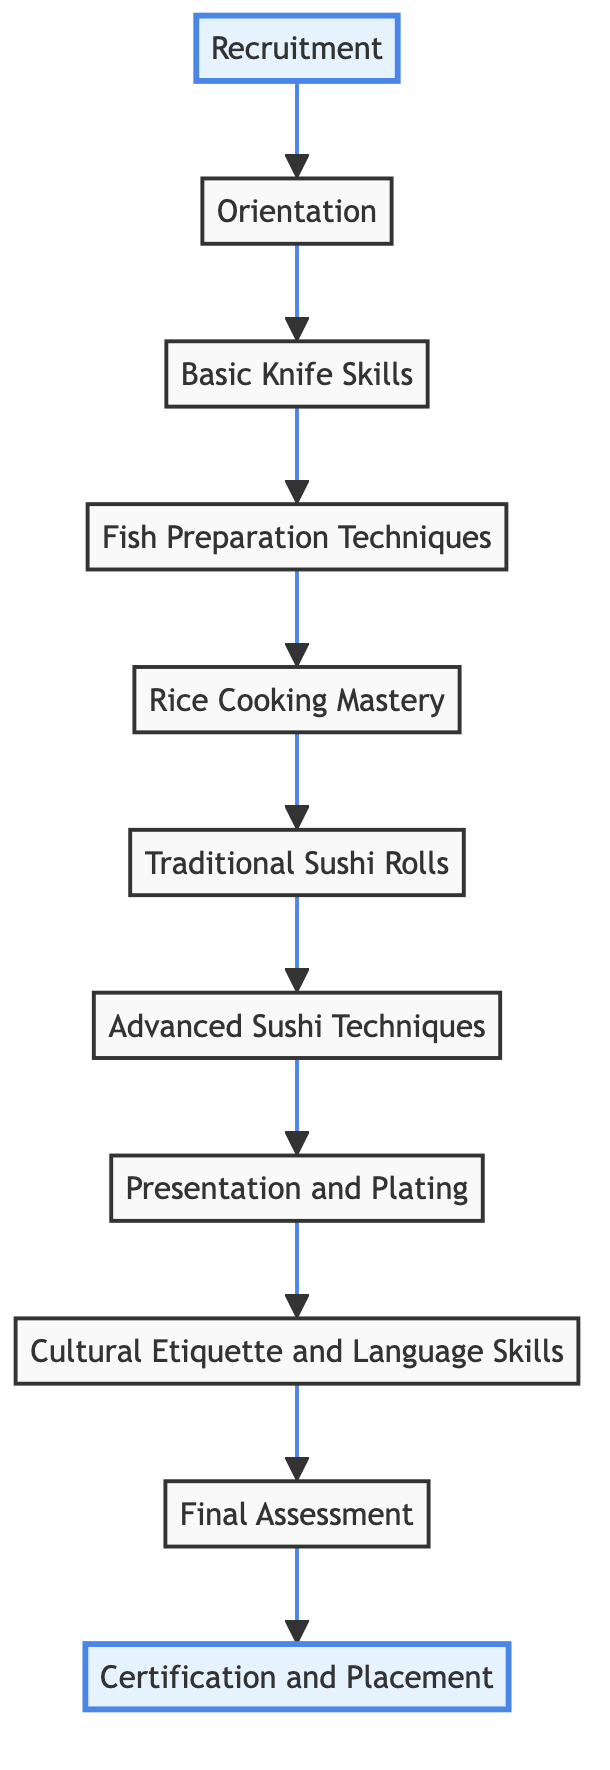What is the first step in the training pipeline? The diagram shows "Recruitment" as the initial node, indicating it's the first step in the training pipeline for modern sushi chefs.
Answer: Recruitment How many nodes are there in the diagram? By counting each distinct step or node described in the flow chart, there are 11 nodes listed from Recruitment to Certification and Placement.
Answer: 11 What comes after "Rice Cooking Mastery"? The flow chart indicates that after "Rice Cooking Mastery," the next step is "Traditional Sushi Rolls."
Answer: Traditional Sushi Rolls Which node represents the final stage of the training pipeline? The last node in the flow chart is labeled "Certification and Placement," representing the endpoint of the training pipeline.
Answer: Certification and Placement What is taught directly before "Presentation and Plating"? According to the flow chart, "Cultural Etiquette and Language Skills" is the step that comes just before "Presentation and Plating."
Answer: Cultural Etiquette and Language Skills How many training steps involve fish preparation? The diagram includes "Fish Preparation Techniques" and "Advanced Sushi Techniques," both of which involve processes related to fish preparation, totaling two steps.
Answer: 2 What training topic comes last before the final assessment? "Cultural Etiquette and Language Skills" is the last training topic outlined before the "Final Assessment."
Answer: Cultural Etiquette and Language Skills Which training phase precedes the advanced techniques of sushi? Just before progressing to "Advanced Sushi Techniques," the training phase is "Traditional Sushi Rolls," highlighting the sequence from basic to advanced skills.
Answer: Traditional Sushi Rolls What is the purpose of the "Final Assessment" node? The "Final Assessment" node serves to evaluate the chef’s practical skills and readiness, marking a critical review point prior to certification.
Answer: Performance review and practical exam 